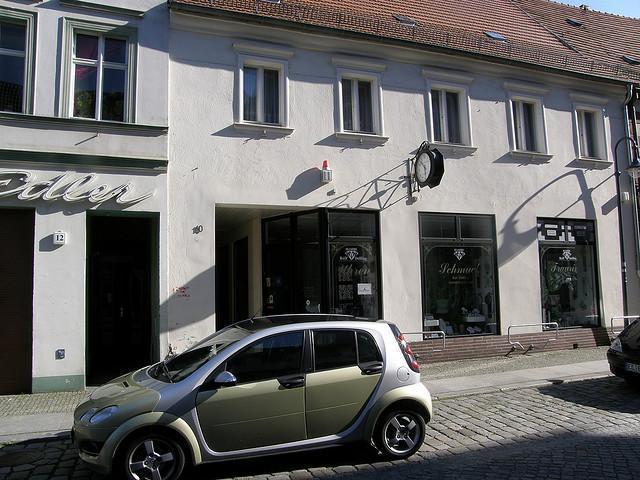How many air conditioning units are present?
Give a very brief answer. 0. 